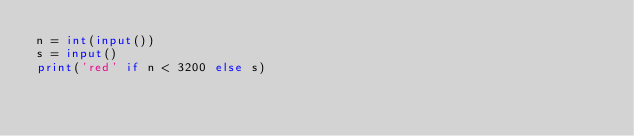Convert code to text. <code><loc_0><loc_0><loc_500><loc_500><_Python_>n = int(input())
s = input()
print('red' if n < 3200 else s)
</code> 